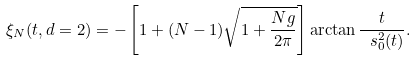<formula> <loc_0><loc_0><loc_500><loc_500>\xi _ { N } ( t , d = 2 ) = - \left [ 1 + ( N - 1 ) \sqrt { 1 + \frac { N g } { 2 \pi } } \right ] \arctan { \frac { t } { \ s _ { 0 } ^ { 2 } ( t ) } } .</formula> 